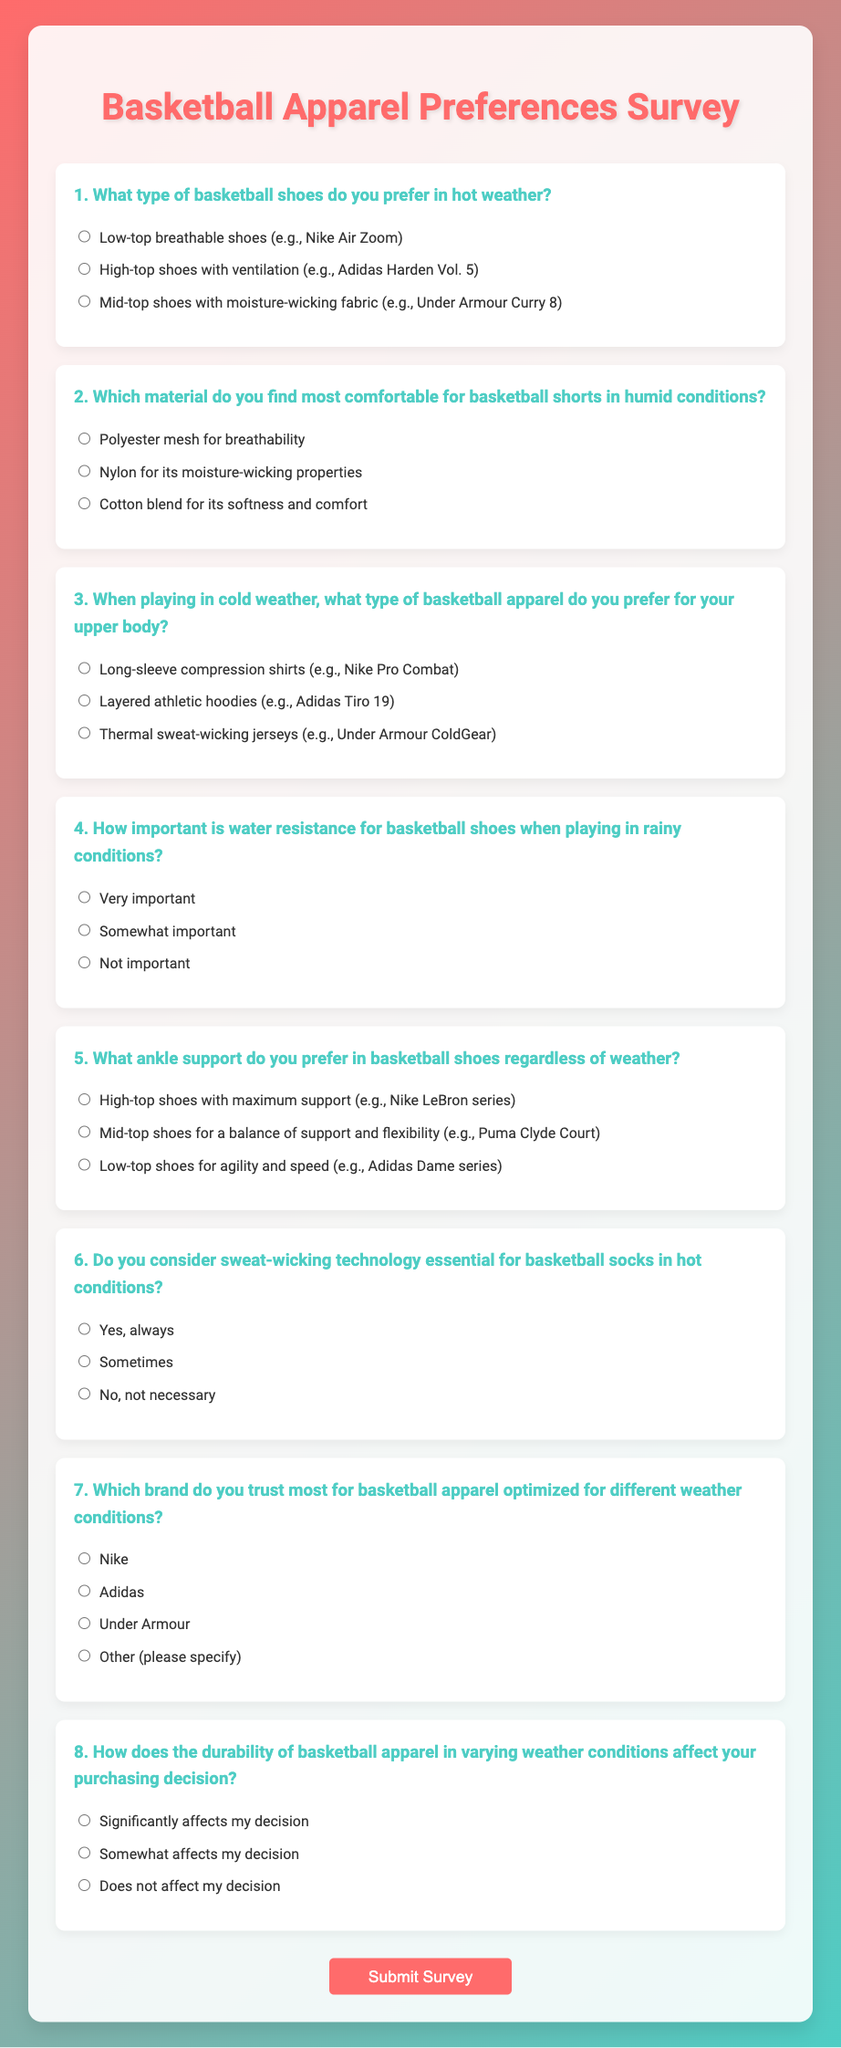What is the title of the survey? The title of the survey is prominently displayed at the top of the document.
Answer: Basketball Apparel Preferences Survey How many questions are included in the survey? The document contains a total of eight questions related to basketball apparel preferences.
Answer: 8 What is the color of the container background? The background color of the container has a white shade with some transparency.
Answer: White Which brand is listed as an option that respondents can trust for basketball apparel? Respondents can choose Nike, which is one of the options given in the survey.
Answer: Nike What type of apparel is questioned for comfort in humid weather? The survey specifically asks about basketball shorts in humid conditions.
Answer: Basketball shorts How does the durability of basketball apparel affect purchasing decisions according to the survey? The survey inquires how significantly durability affects the respondents' decisions when purchasing basketball apparel.
Answer: Significantly affects my decision 